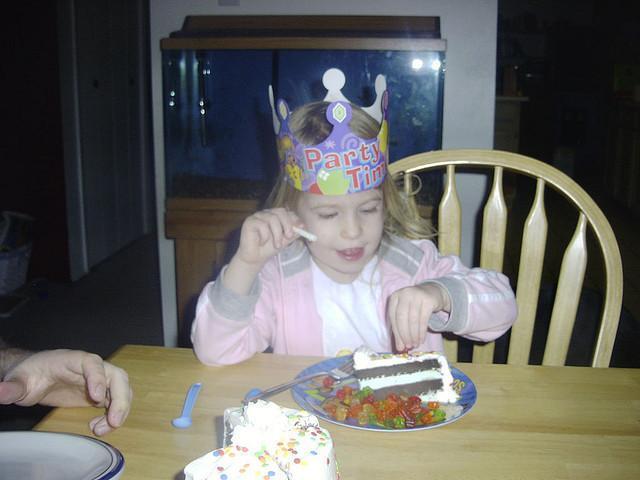How many spoons are touching the plate?
Give a very brief answer. 0. How many people are in the photo?
Give a very brief answer. 2. How many cakes are there?
Give a very brief answer. 2. How many women on bikes are in the picture?
Give a very brief answer. 0. 